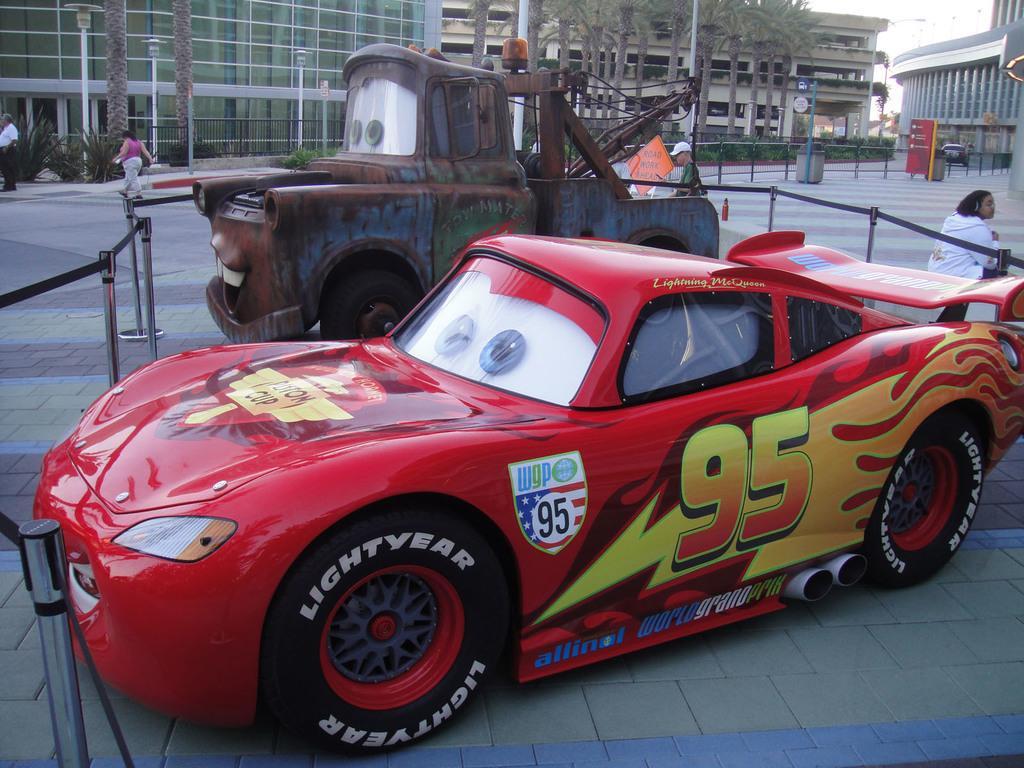Could you give a brief overview of what you see in this image? In this picture I can observe red color car. In front of the car there is a ribbon. In the background there are buildings and trees. 